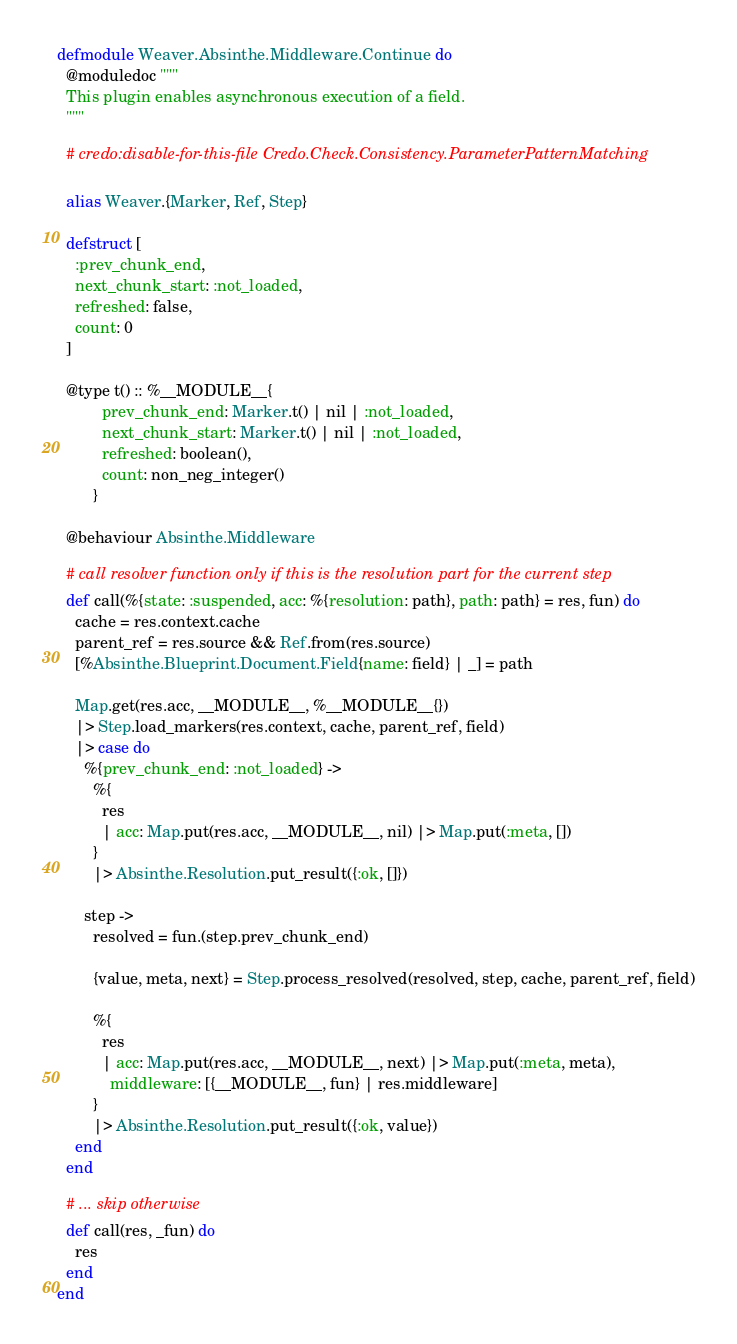<code> <loc_0><loc_0><loc_500><loc_500><_Elixir_>defmodule Weaver.Absinthe.Middleware.Continue do
  @moduledoc """
  This plugin enables asynchronous execution of a field.
  """

  # credo:disable-for-this-file Credo.Check.Consistency.ParameterPatternMatching

  alias Weaver.{Marker, Ref, Step}

  defstruct [
    :prev_chunk_end,
    next_chunk_start: :not_loaded,
    refreshed: false,
    count: 0
  ]

  @type t() :: %__MODULE__{
          prev_chunk_end: Marker.t() | nil | :not_loaded,
          next_chunk_start: Marker.t() | nil | :not_loaded,
          refreshed: boolean(),
          count: non_neg_integer()
        }

  @behaviour Absinthe.Middleware

  # call resolver function only if this is the resolution part for the current step
  def call(%{state: :suspended, acc: %{resolution: path}, path: path} = res, fun) do
    cache = res.context.cache
    parent_ref = res.source && Ref.from(res.source)
    [%Absinthe.Blueprint.Document.Field{name: field} | _] = path

    Map.get(res.acc, __MODULE__, %__MODULE__{})
    |> Step.load_markers(res.context, cache, parent_ref, field)
    |> case do
      %{prev_chunk_end: :not_loaded} ->
        %{
          res
          | acc: Map.put(res.acc, __MODULE__, nil) |> Map.put(:meta, [])
        }
        |> Absinthe.Resolution.put_result({:ok, []})

      step ->
        resolved = fun.(step.prev_chunk_end)

        {value, meta, next} = Step.process_resolved(resolved, step, cache, parent_ref, field)

        %{
          res
          | acc: Map.put(res.acc, __MODULE__, next) |> Map.put(:meta, meta),
            middleware: [{__MODULE__, fun} | res.middleware]
        }
        |> Absinthe.Resolution.put_result({:ok, value})
    end
  end

  # ... skip otherwise
  def call(res, _fun) do
    res
  end
end
</code> 